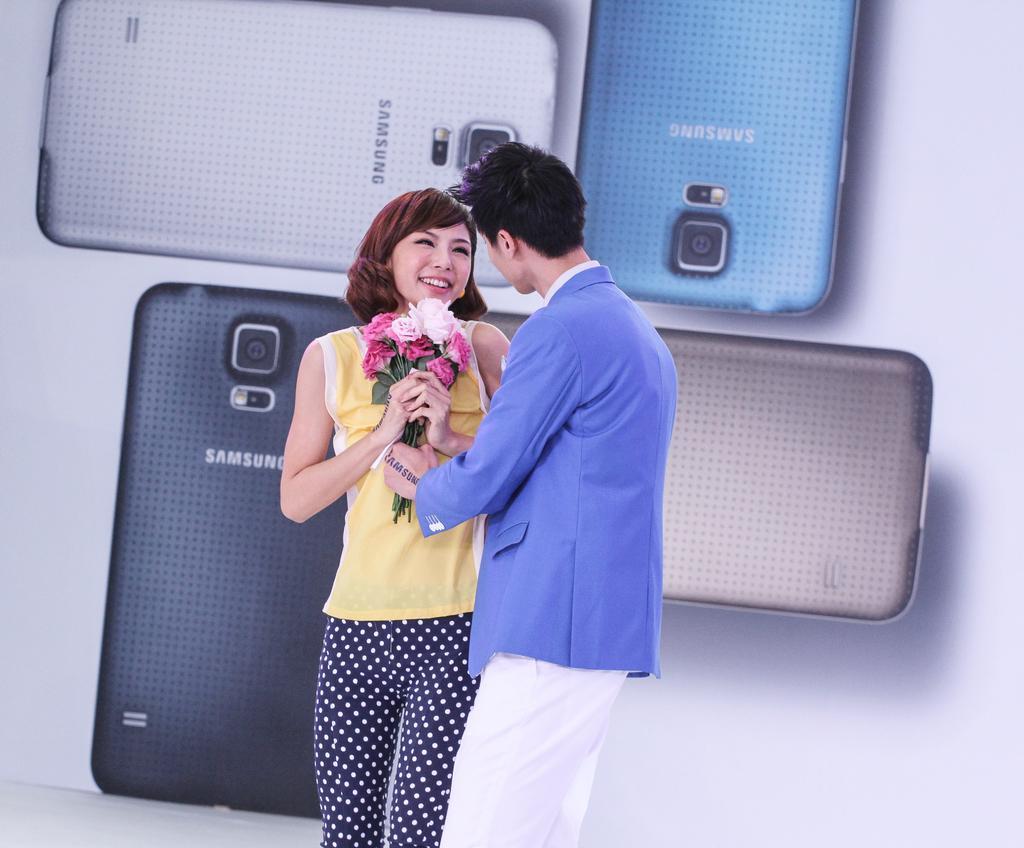Please provide a concise description of this image. In this image in the center there are persons standing. The woman standing in the center is holding flowers and smiling. In the background there is banner with images of mobile phones. 